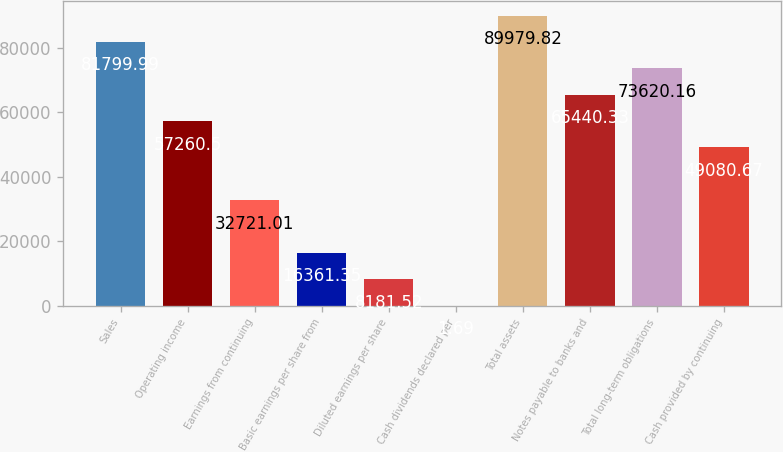Convert chart. <chart><loc_0><loc_0><loc_500><loc_500><bar_chart><fcel>Sales<fcel>Operating income<fcel>Earnings from continuing<fcel>Basic earnings per share from<fcel>Diluted earnings per share<fcel>Cash dividends declared per<fcel>Total assets<fcel>Notes payable to banks and<fcel>Total long-term obligations<fcel>Cash provided by continuing<nl><fcel>81800<fcel>57260.5<fcel>32721<fcel>16361.4<fcel>8181.52<fcel>1.69<fcel>89979.8<fcel>65440.3<fcel>73620.2<fcel>49080.7<nl></chart> 